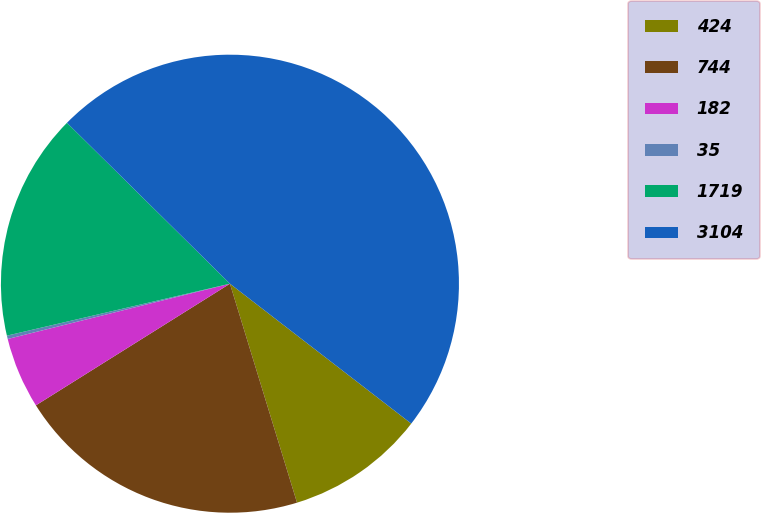Convert chart to OTSL. <chart><loc_0><loc_0><loc_500><loc_500><pie_chart><fcel>424<fcel>744<fcel>182<fcel>35<fcel>1719<fcel>3104<nl><fcel>9.81%<fcel>20.82%<fcel>5.03%<fcel>0.24%<fcel>16.04%<fcel>48.06%<nl></chart> 